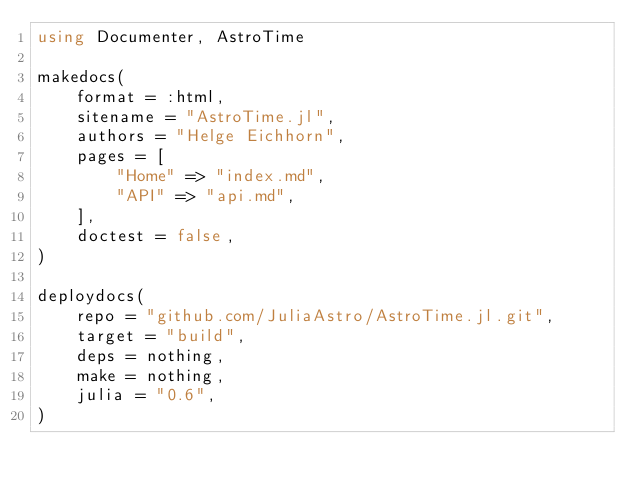<code> <loc_0><loc_0><loc_500><loc_500><_Julia_>using Documenter, AstroTime

makedocs(
    format = :html,
    sitename = "AstroTime.jl",
    authors = "Helge Eichhorn",
    pages = [
        "Home" => "index.md",
        "API" => "api.md",
    ],
    doctest = false,
)

deploydocs(
    repo = "github.com/JuliaAstro/AstroTime.jl.git",
    target = "build",
    deps = nothing,
    make = nothing,
    julia = "0.6",
)
</code> 